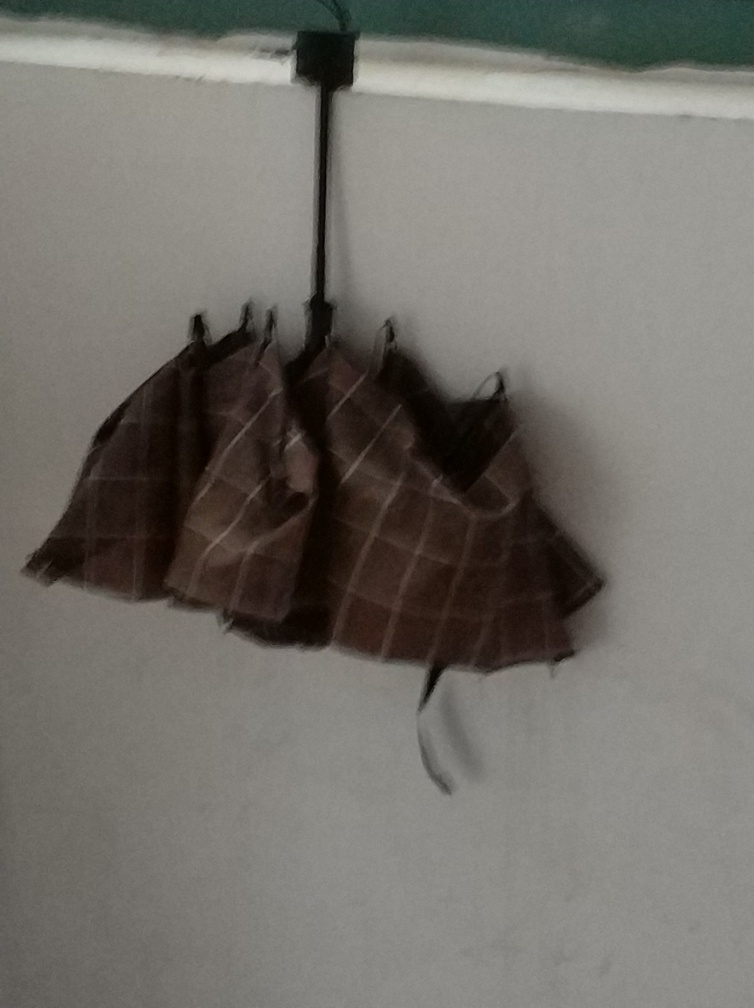What can you tell me about the item hanging on the wall? The item hanging on the wall appears to be a folded piece of fabric, possibly a garment or a cloth. It's attached to the wall via a set of clips or hooks, which suggests it might be set out to dry or displayed for some purpose. Can you speculate on the type of room this is based on the image? It's difficult to determine the type of room with certainty from this single image. However, the plain wall and the functional way the cloth is hung suggest it might be a utilitarian space, such as a laundry room, storage area, or a backstage area of a theater. 